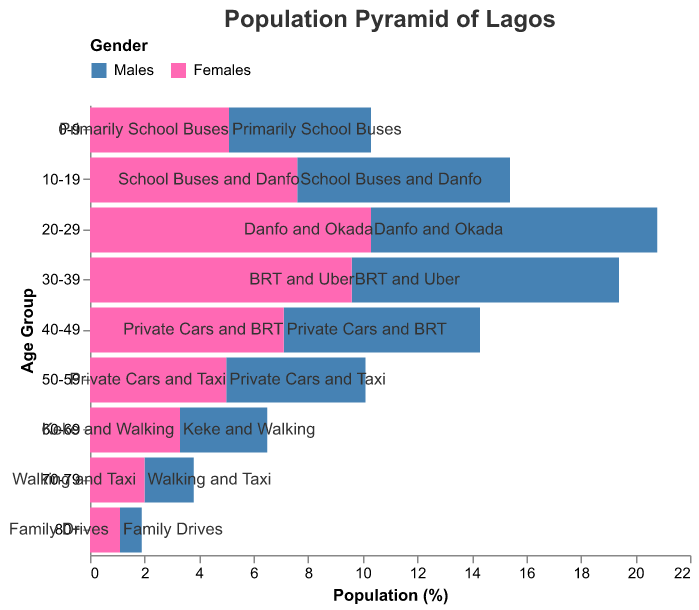Which age group has the highest proportion of males? The age group 20-29 has the largest negative value for males, which indicates that it has the highest proportion of males.
Answer: 20-29 What transportation preference is associated with the age group 60-69? The tooltip and the age group 60-69 indicate that this group prefers "Keke and Walking".
Answer: Keke and Walking How do the population proportions of females in the age group 0-9 and 10-19 compare? The population proportion of females in the age group 0-9 is 5.1, while it is 7.6 in the age group 10-19. The 10-19 group is higher.
Answer: 10-19 has a higher proportion What is the difference in population percentage between males and females in the age group 50-59? The proportion for males in 50-59 is -5.1, and for females, it is 5.0. The difference is 5.0 - (-5.1) = 10.1.
Answer: 10.1 What is the common transportation preference for individuals aged 70-79? The tooltip for the age group 70-79 indicates a preference for "Walking and Taxi".
Answer: Walking and Taxi Which gender has a greater population proportion in the age group 30-39? The proportion of females (9.6) in the age group 30-39 is higher than that of males (-9.8). After converting the negative to positive for comparison, females still have a slightly higher population proportion.
Answer: Females How do the population proportions of males in the age groups 40-49 and 50-59 compare? The proportion of males in the age group 40-49 is -7.2, while it is -5.1 in the age group 50-59. The age group 40-49 has a higher (more negative) proportion.
Answer: 40-49 is higher What is the transportation preference for the age group with the smallest population of males? The age group 80+ has the smallest proportion of males at -0.8, and their transportation preference is "Family Drives".
Answer: Family Drives 